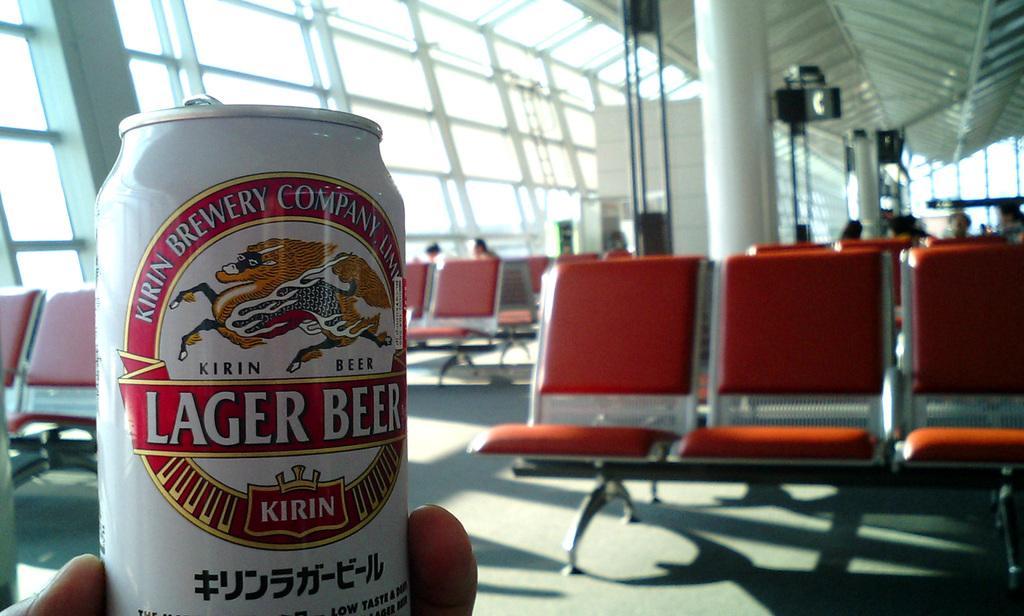Can you describe this image briefly? In this image on the left side we can see a tin in the person's fingers. In the background there are chairs on the floor, few persons, glass doors, poles, boards, pillar, objects and roof. 